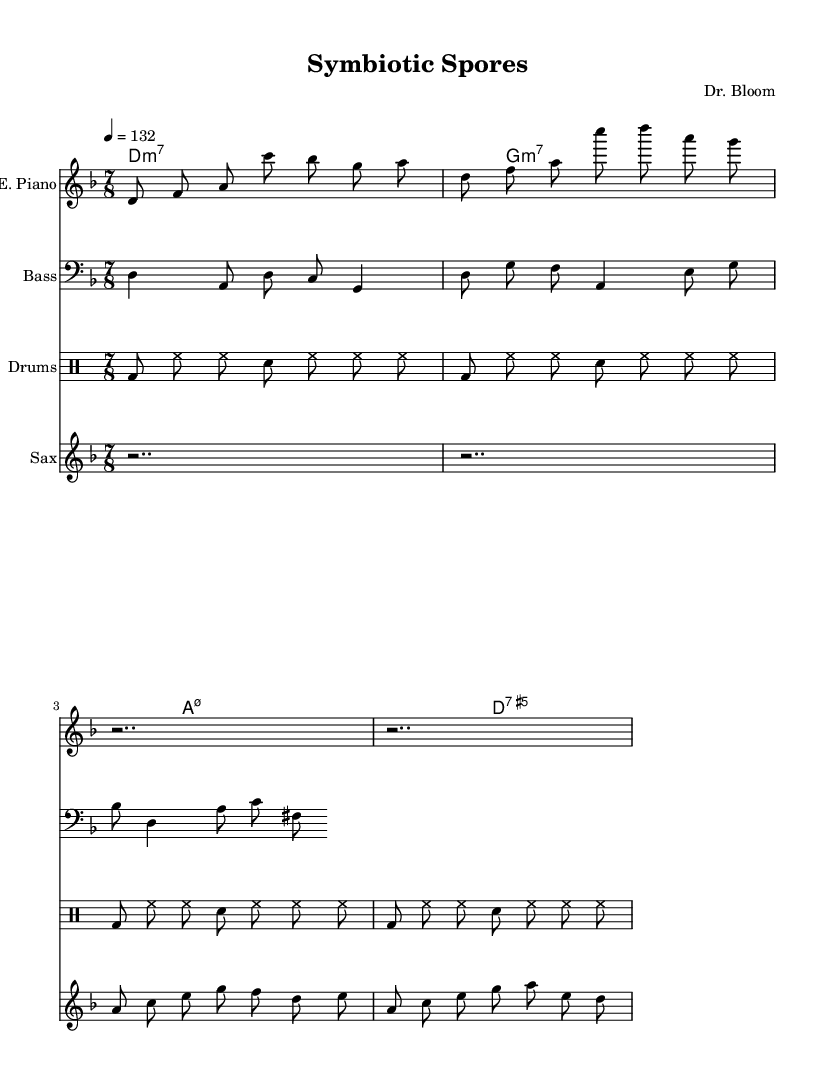What is the key signature of this music? The key signature is D minor, which has one flat (B flat). It can be identified at the beginning of the staff, where the flat symbol appears.
Answer: D minor What is the time signature of this music? The time signature is 7/8, indicated right after the key signature. This means there are seven eighth notes in each measure.
Answer: 7/8 What is the tempo marking for this piece? The tempo marking is 4 = 132, which is located at the beginning of the score. This means the metronome should be set to 132 beats per minute for a quarter note.
Answer: 132 How many measures are in the bass guitar part? The bass guitar part consists of 4 measures. Each measure is separated by vertical lines, and you can count the total number of measures.
Answer: 4 What type of jazz ensemble is represented in this sheet music? The ensemble consists of an electric piano, bass guitar, drums, and saxophone, which are typical of a jazz fusion group. This combination shows the collaboration between rhythm and melodic instruments.
Answer: Jazz fusion What is the rhythmic pattern used in the drum part? The drum part contains a consistent pattern of bass drum and hi-hat with snare accents, typical in 7/8 time, giving a swing feel throughout the piece.
Answer: Swing pattern What is the title of this music? The title "Symbiotic Spores" is indicated in the header section of the sheet music, specifying the unique botanical theme of the composition.
Answer: Symbiotic Spores 